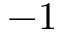<formula> <loc_0><loc_0><loc_500><loc_500>- 1</formula> 